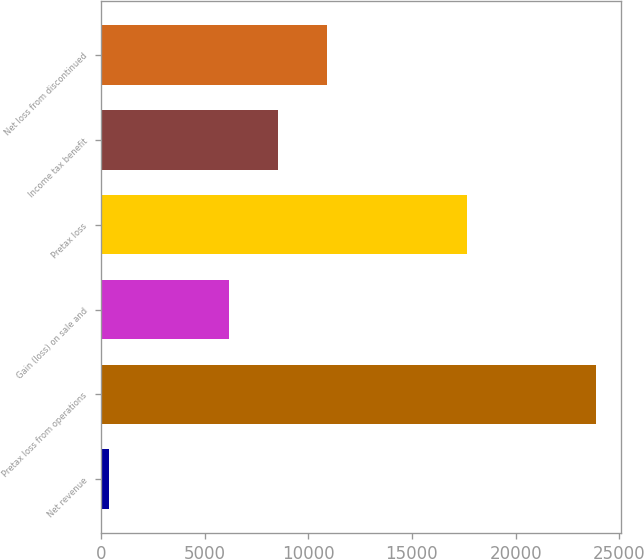<chart> <loc_0><loc_0><loc_500><loc_500><bar_chart><fcel>Net revenue<fcel>Pretax loss from operations<fcel>Gain (loss) on sale and<fcel>Pretax loss<fcel>Income tax benefit<fcel>Net loss from discontinued<nl><fcel>372<fcel>23872<fcel>6194<fcel>17678<fcel>8544<fcel>10894<nl></chart> 